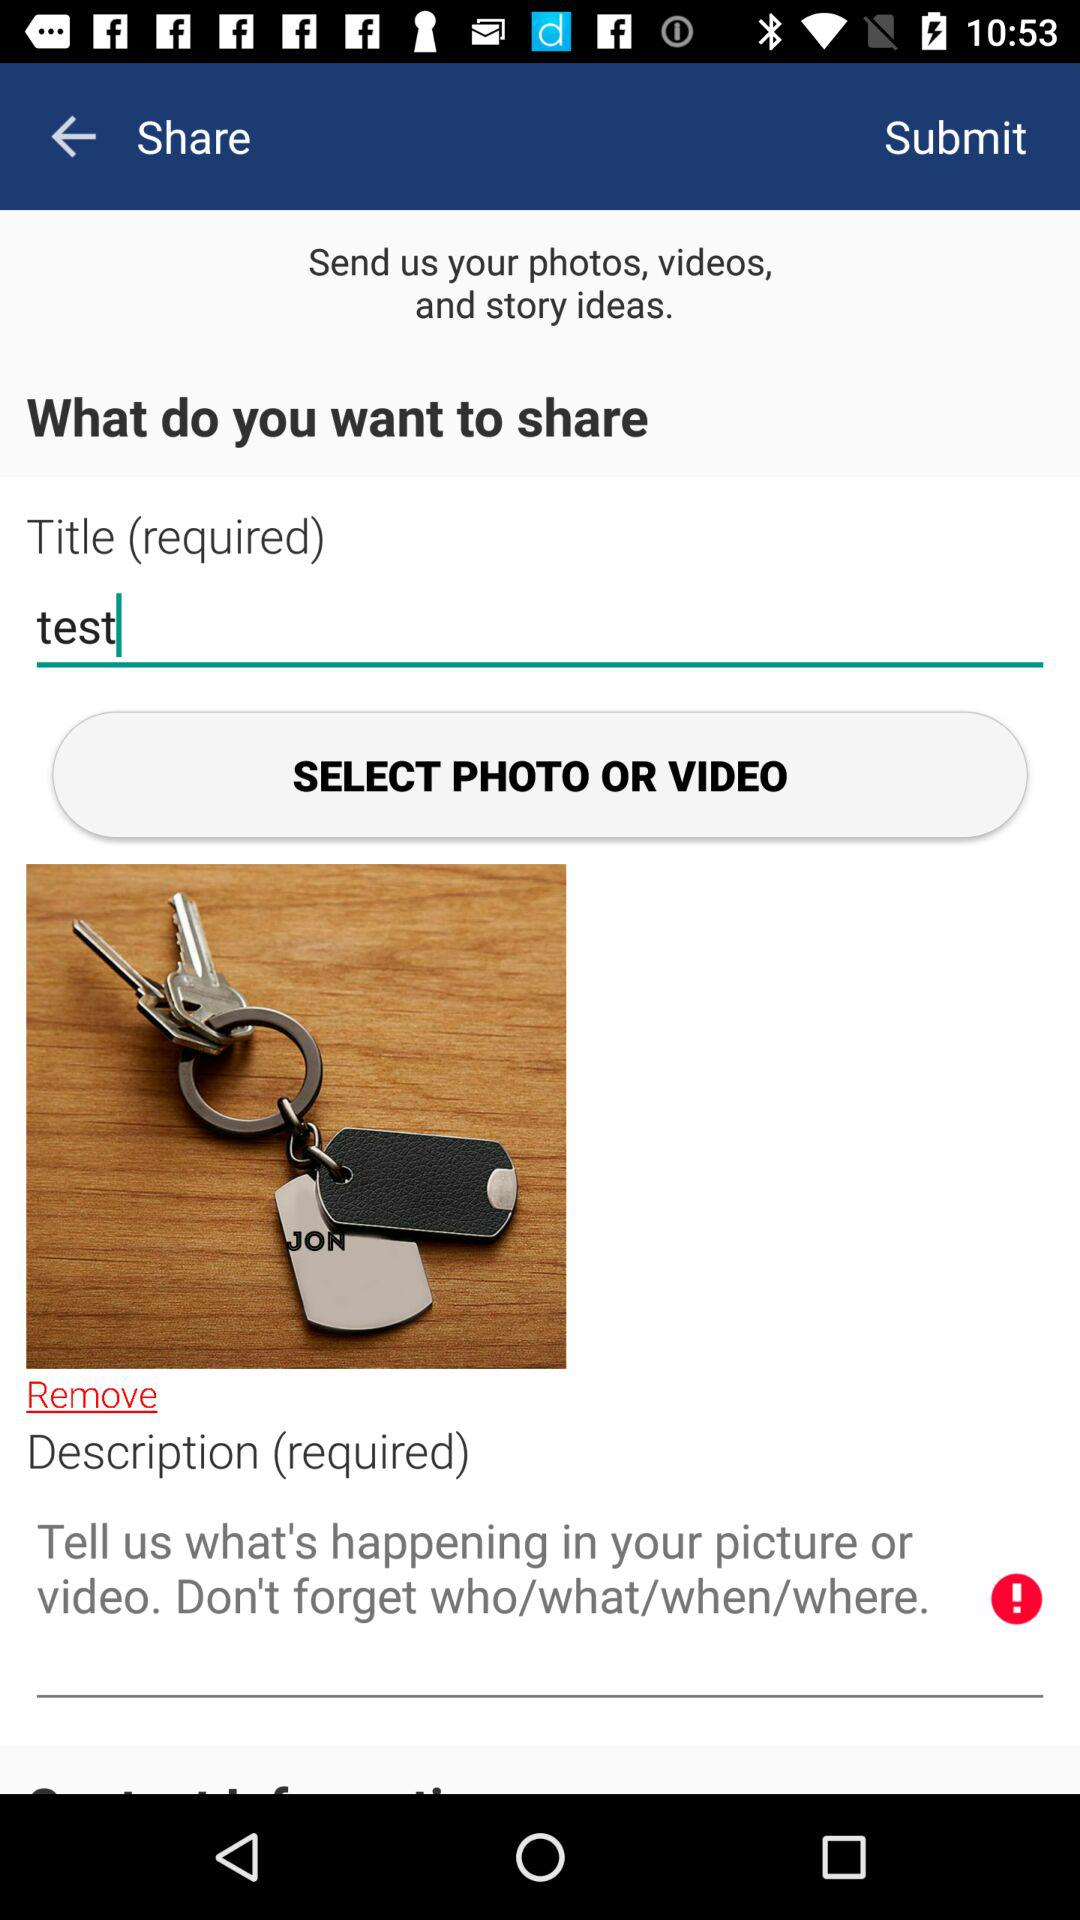How many text inputs are required?
Answer the question using a single word or phrase. 2 